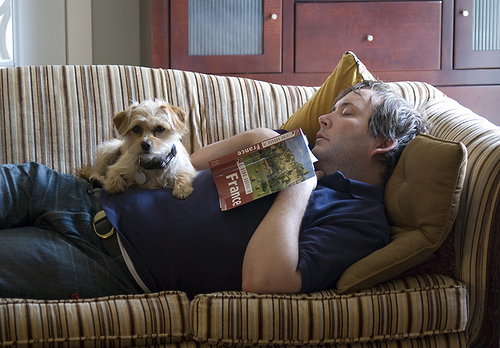<image>
Is there a man behind the sofa? No. The man is not behind the sofa. From this viewpoint, the man appears to be positioned elsewhere in the scene. Is there a dog on the couch? Yes. Looking at the image, I can see the dog is positioned on top of the couch, with the couch providing support. Where is the dog in relation to the book? Is it on the book? No. The dog is not positioned on the book. They may be near each other, but the dog is not supported by or resting on top of the book. 